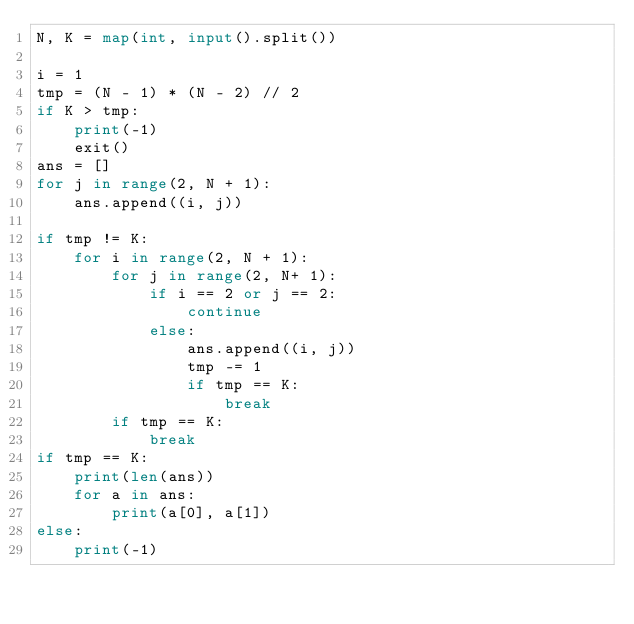<code> <loc_0><loc_0><loc_500><loc_500><_Python_>N, K = map(int, input().split())

i = 1
tmp = (N - 1) * (N - 2) // 2
if K > tmp:
    print(-1)
    exit()
ans = []
for j in range(2, N + 1):
    ans.append((i, j))

if tmp != K:
    for i in range(2, N + 1):
        for j in range(2, N+ 1):
            if i == 2 or j == 2:
                continue
            else:
                ans.append((i, j))
                tmp -= 1
                if tmp == K:
                    break
        if tmp == K:
            break
if tmp == K:
    print(len(ans))
    for a in ans:
        print(a[0], a[1])
else:
    print(-1)
</code> 